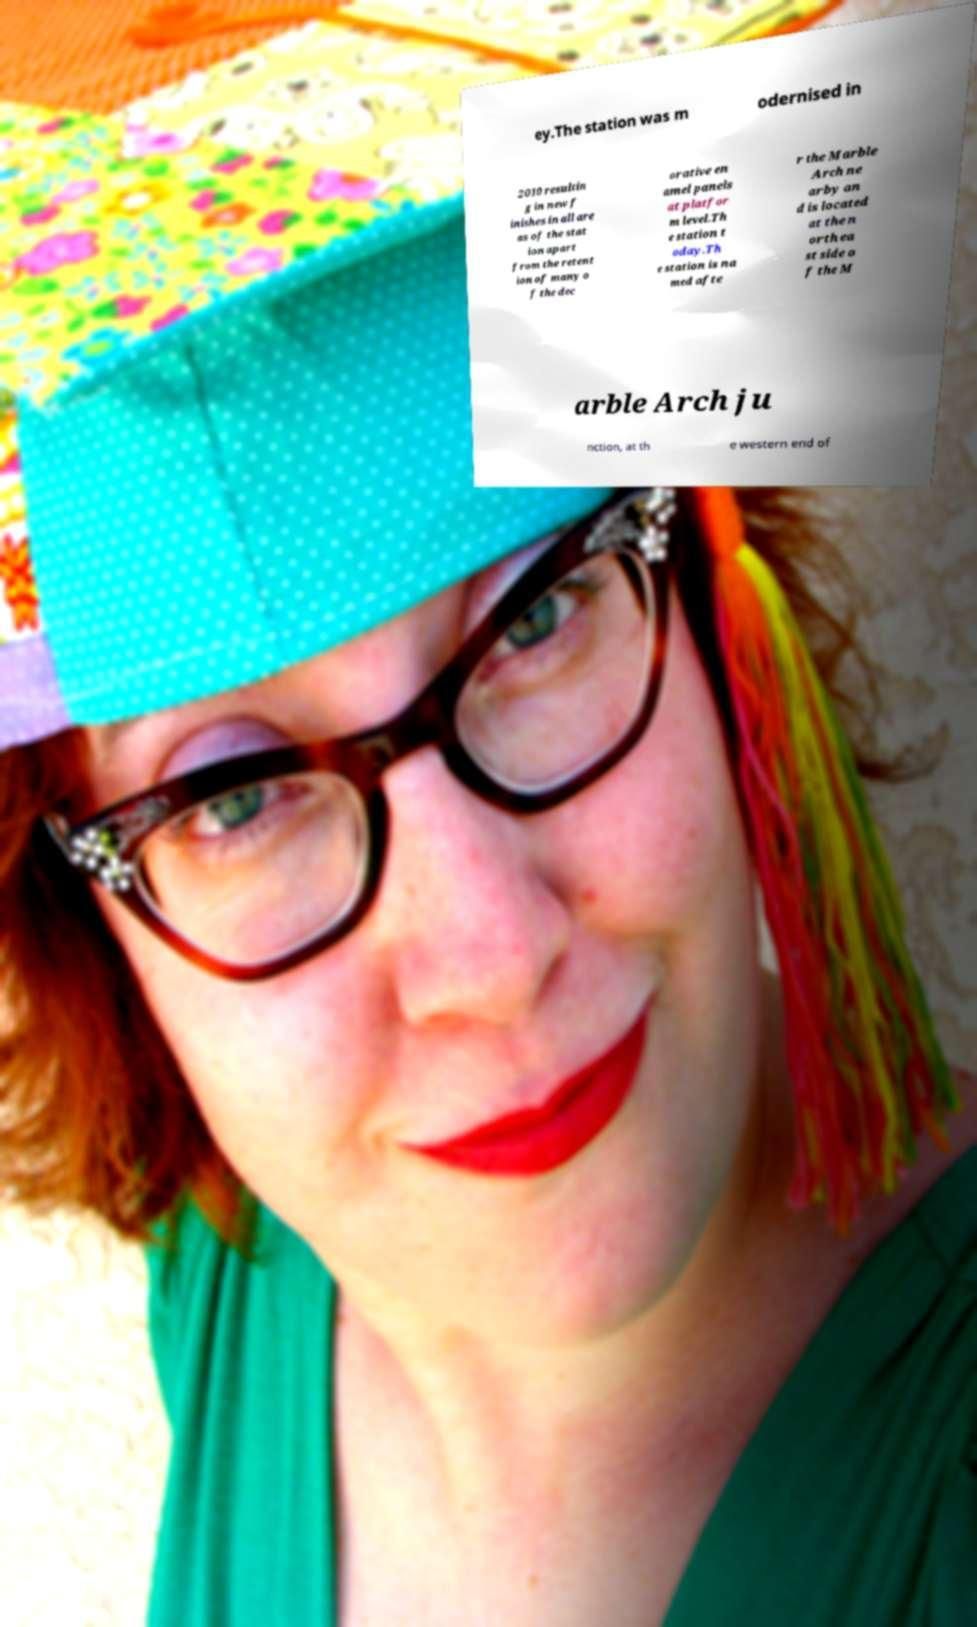Can you accurately transcribe the text from the provided image for me? ey.The station was m odernised in 2010 resultin g in new f inishes in all are as of the stat ion apart from the retent ion of many o f the dec orative en amel panels at platfor m level.Th e station t oday.Th e station is na med afte r the Marble Arch ne arby an d is located at the n orth ea st side o f the M arble Arch ju nction, at th e western end of 